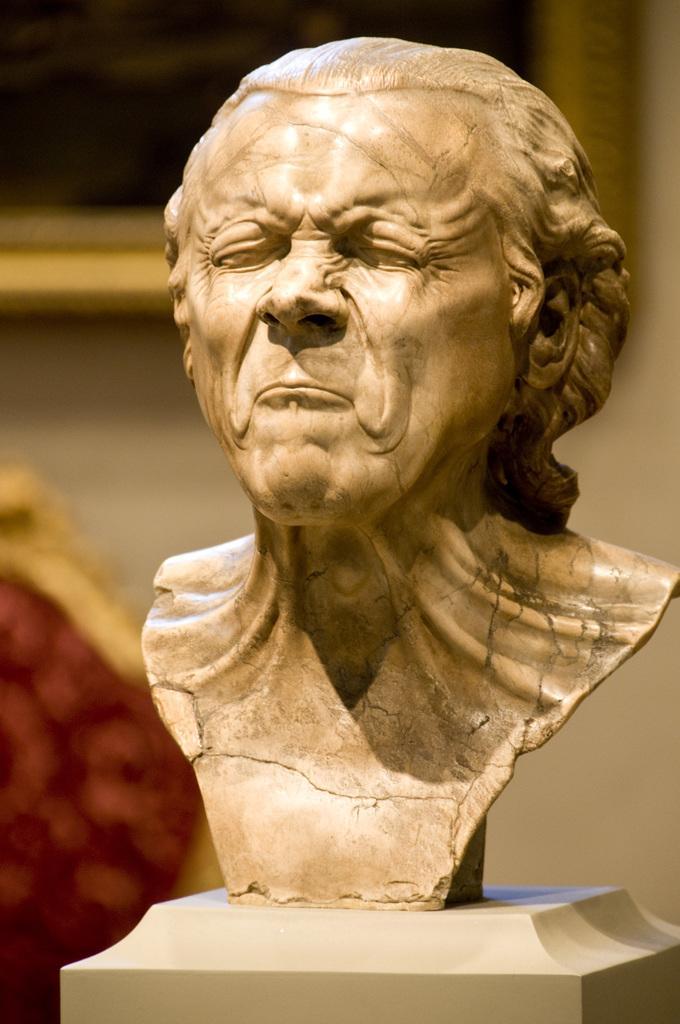In one or two sentences, can you explain what this image depicts? In this image in the center there is one sculpture, and in the background there is wall, and photo frame and some object. 